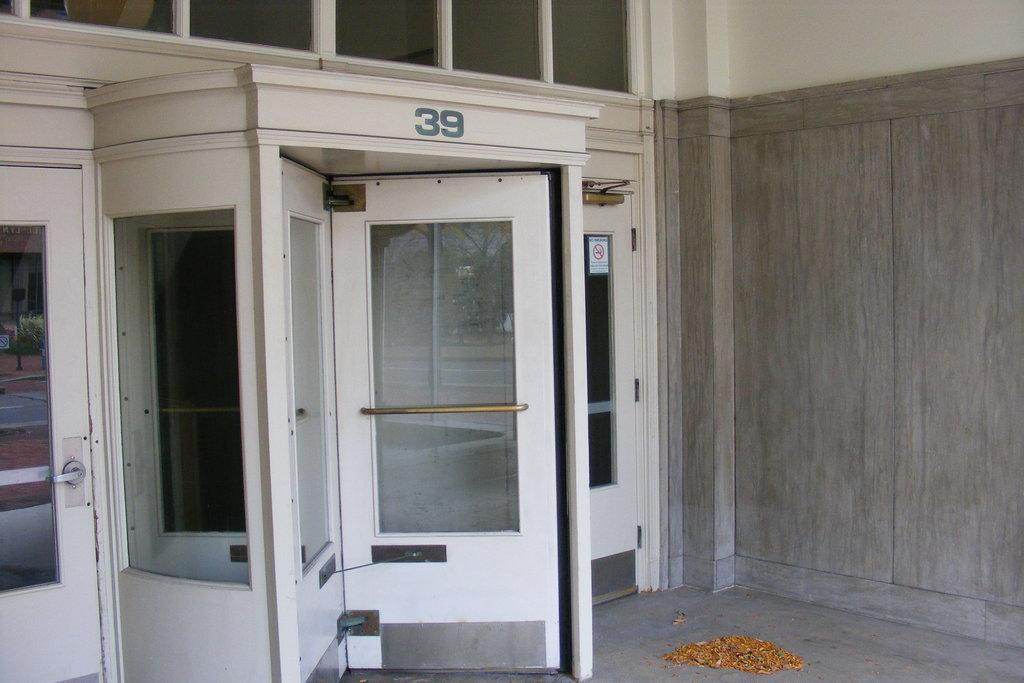Provide a one-sentence caption for the provided image. The carousel entrance to a building has the number 39 displayed above it. 